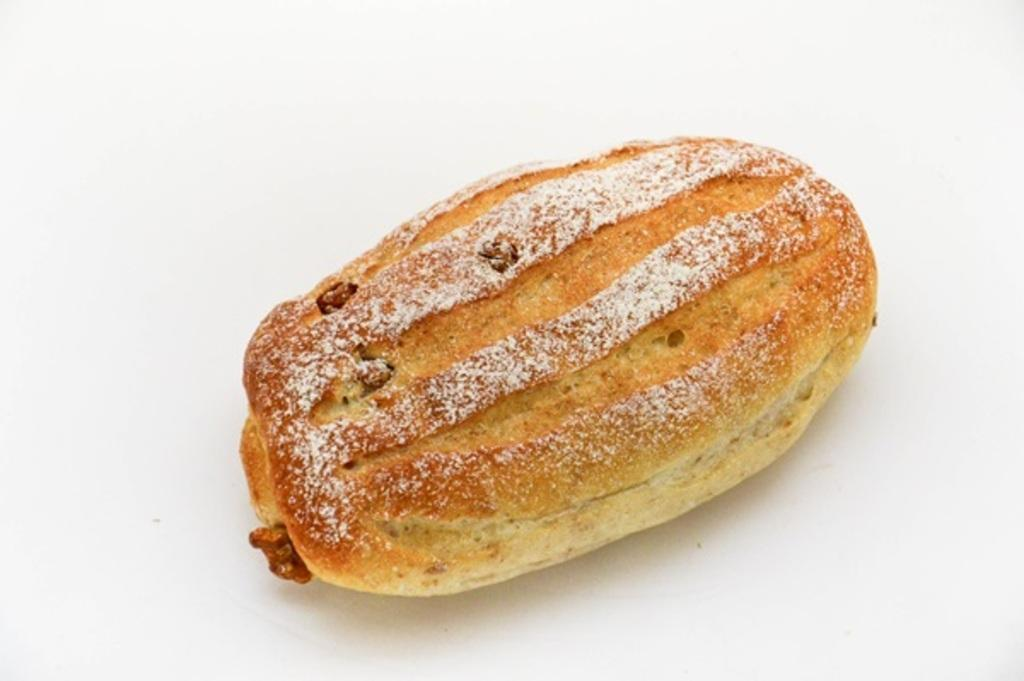What is the main subject of the image? There is a food item in the image. What color is the background of the image? The background of the image is white in color. What type of apparel is being worn by the food item in the image? There is no apparel present in the image, as the main subject is a food item. What is the fuel source for the roof in the image? There is no roof or fuel source present in the image; it only features a food item and a white background. 